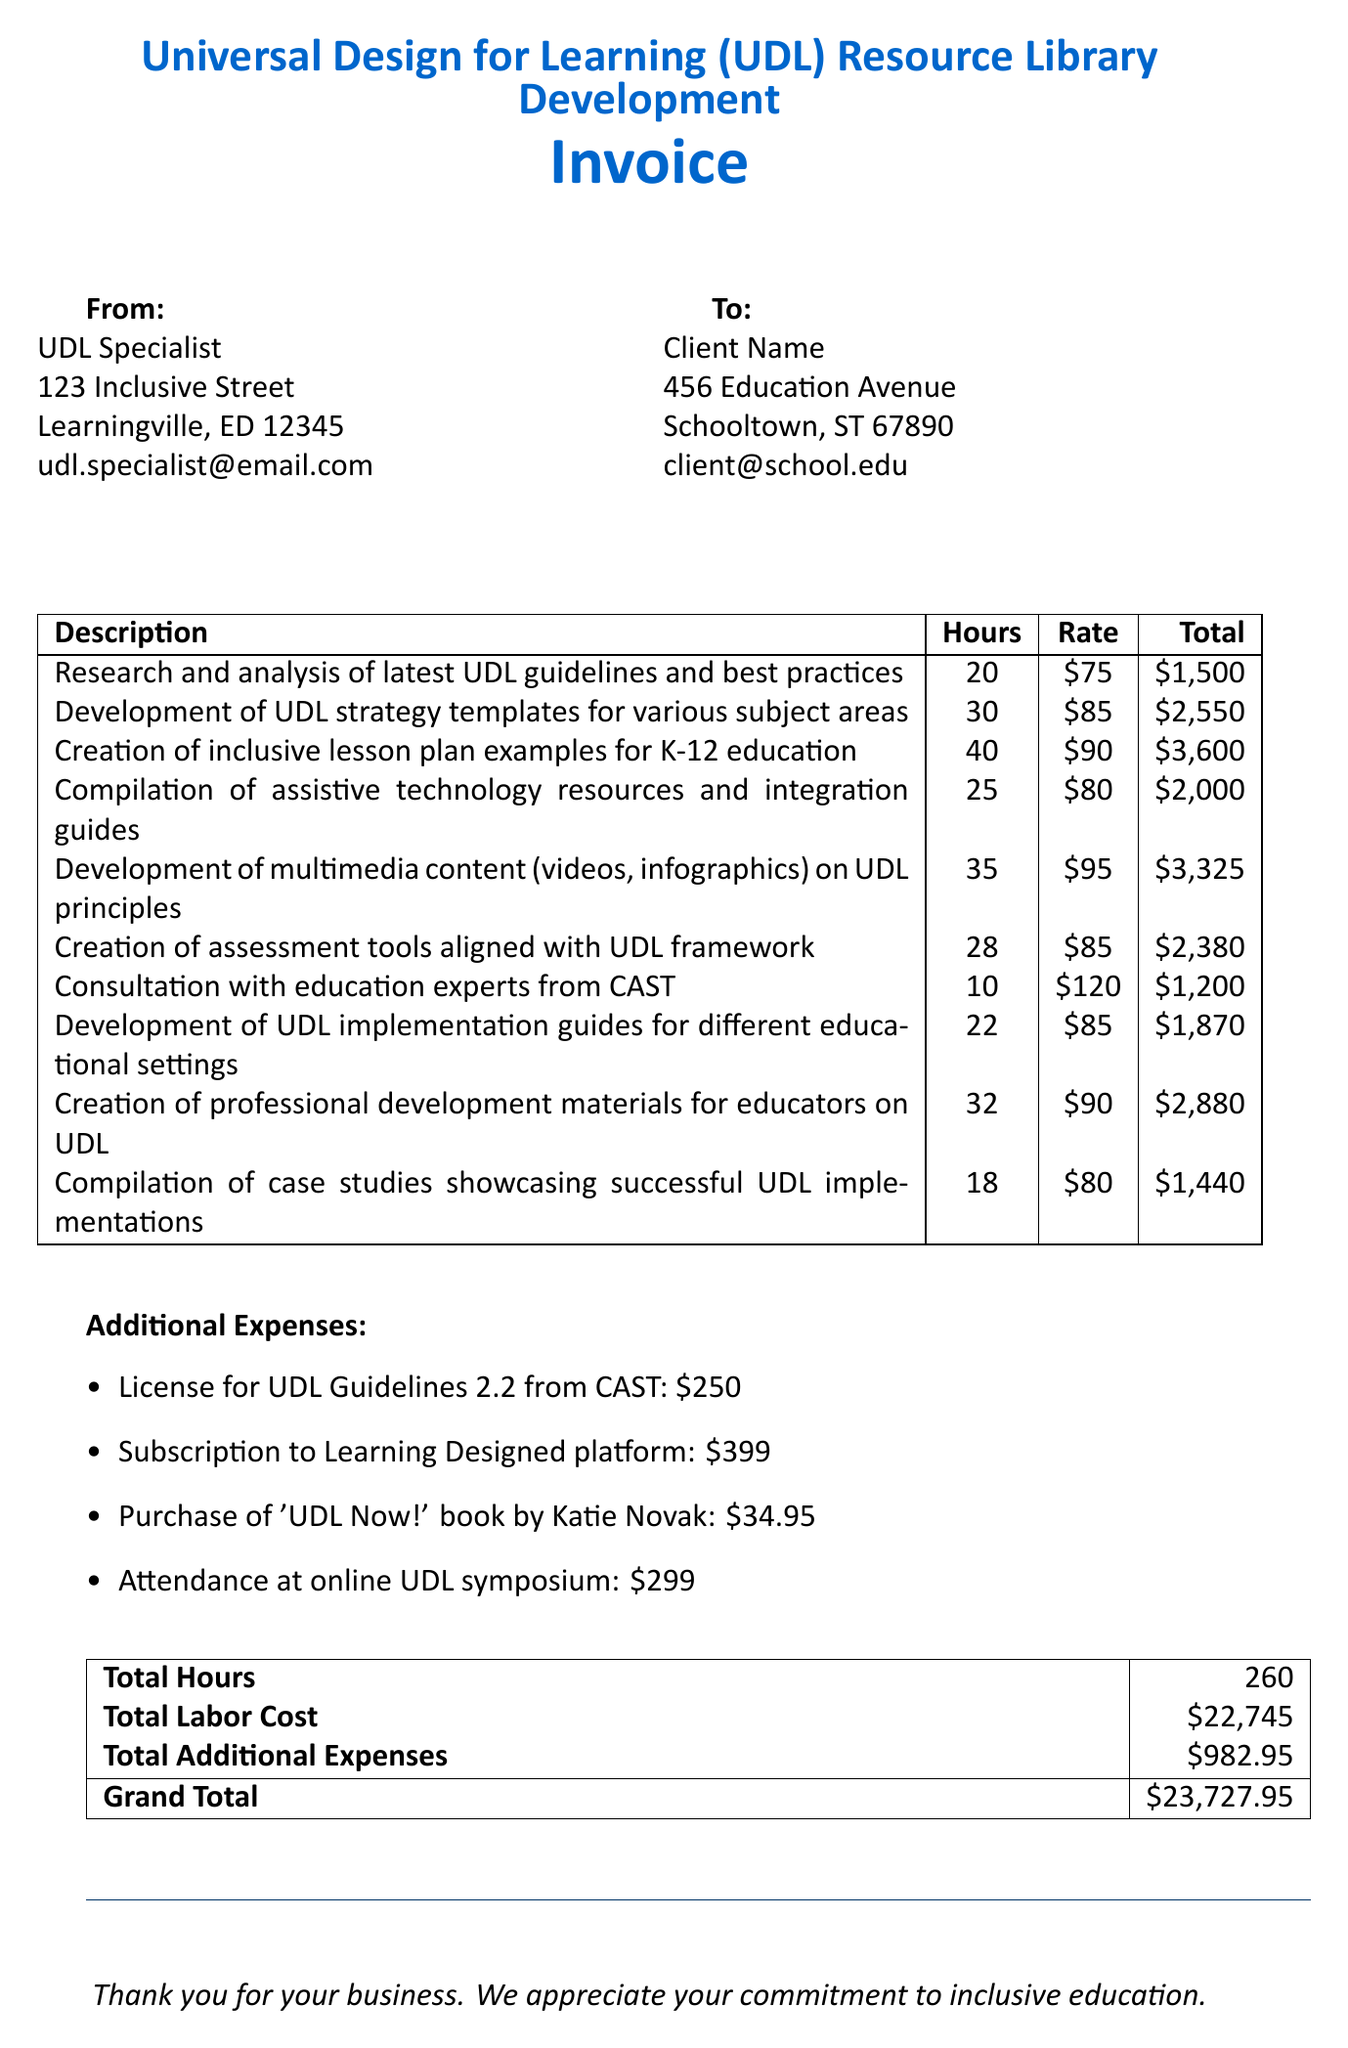what is the total labor cost? The total labor cost is detailed in the invoice as $22,745.
Answer: $22,745 how many hours were spent on the creation of inclusive lesson plan examples? The invoice states that 40 hours were dedicated to the creation of inclusive lesson plans.
Answer: 40 what is the cost of the license for UDL Guidelines 2.2 from CAST? The invoice lists the cost for the license as $250.
Answer: $250 who was consulted from CAST during the project? The invoice mentions consultation with education experts from CAST.
Answer: education experts from CAST what is the total of additional expenses? The additional expenses total is provided in the invoice as $982.95.
Answer: $982.95 which item has the highest total charge? The item with the highest total charge is the creation of inclusive lesson plan examples for K-12 education, totaling $3,600.
Answer: Creation of inclusive lesson plan examples for K-12 education how many hours were allocated for the development of multimedia content? The invoice indicates that 35 hours were spent on the development of multimedia content.
Answer: 35 what is the grand total amount due? The grand total amount due, as specified in the document, is $23,727.95.
Answer: $23,727.95 how many different types of additional expenses are listed? There are four different additional expenses listed in the invoice.
Answer: four 